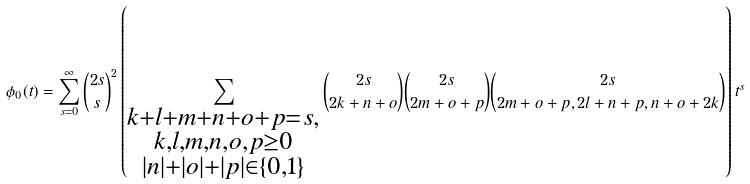Convert formula to latex. <formula><loc_0><loc_0><loc_500><loc_500>\phi _ { 0 } ( t ) = \sum _ { s = 0 } ^ { \infty } { 2 s \choose s } ^ { 2 } \left ( \sum _ { \substack { k + l + m + n + o + p = s , \\ k , l , m , n , o , p \geq 0 \\ | n | + | o | + | p | \in \{ 0 , 1 \} } } { 2 s \choose 2 k + n + o } { 2 s \choose 2 m + o + p } { 2 s \choose 2 m + o + p , 2 l + n + p , n + o + 2 k } \right ) t ^ { s }</formula> 